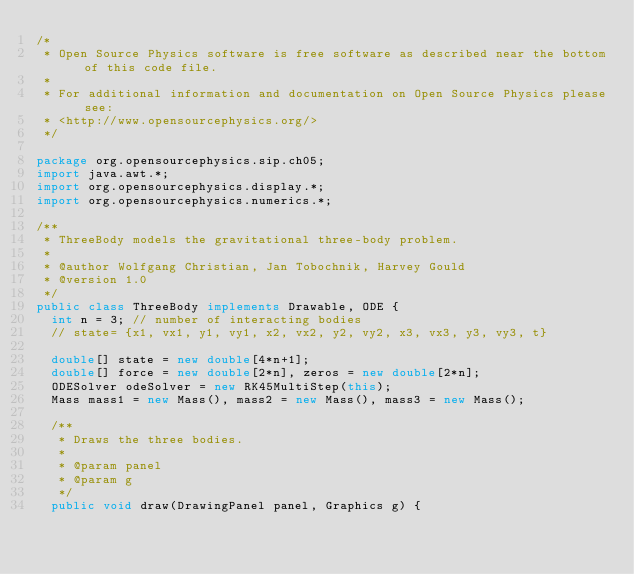Convert code to text. <code><loc_0><loc_0><loc_500><loc_500><_Java_>/*
 * Open Source Physics software is free software as described near the bottom of this code file.
 *
 * For additional information and documentation on Open Source Physics please see: 
 * <http://www.opensourcephysics.org/>
 */

package org.opensourcephysics.sip.ch05;
import java.awt.*;
import org.opensourcephysics.display.*;
import org.opensourcephysics.numerics.*;

/**
 * ThreeBody models the gravitational three-body problem.
 *
 * @author Wolfgang Christian, Jan Tobochnik, Harvey Gould
 * @version 1.0
 */
public class ThreeBody implements Drawable, ODE {
  int n = 3; // number of interacting bodies
  // state= {x1, vx1, y1, vy1, x2, vx2, y2, vy2, x3, vx3, y3, vy3, t}

  double[] state = new double[4*n+1];
  double[] force = new double[2*n], zeros = new double[2*n];
  ODESolver odeSolver = new RK45MultiStep(this);
  Mass mass1 = new Mass(), mass2 = new Mass(), mass3 = new Mass();

  /**
   * Draws the three bodies.
   *
   * @param panel
   * @param g
   */
  public void draw(DrawingPanel panel, Graphics g) {</code> 